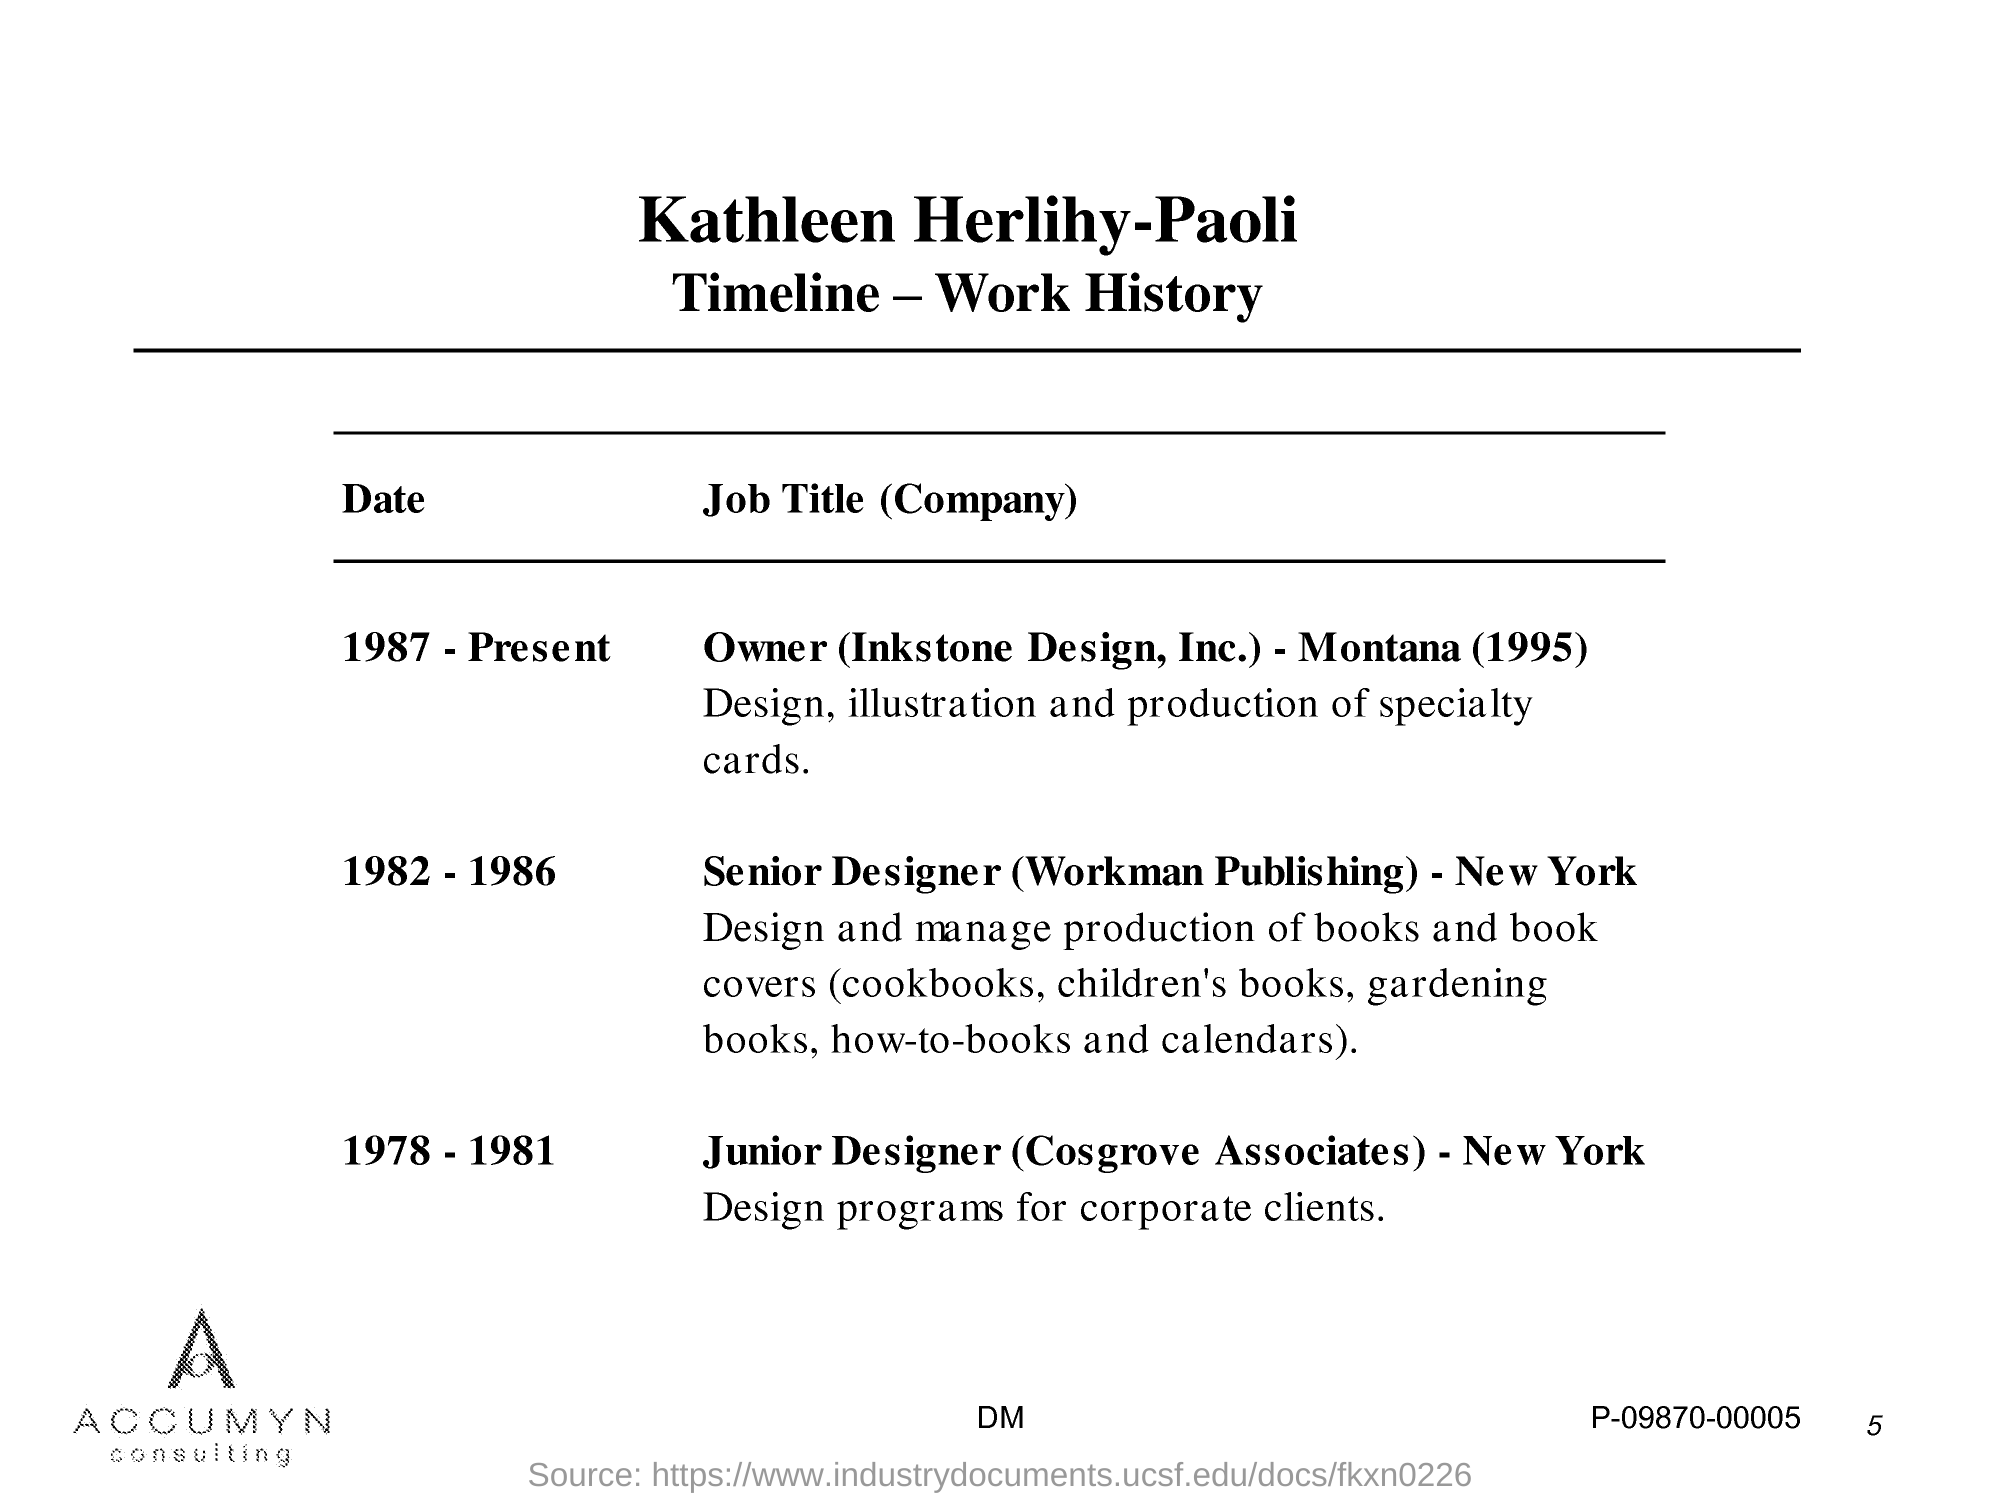List a handful of essential elements in this visual. Kathleen Herlihy-Paoli is the owner of Inkstone Design, Inc. and currently resides in Montana, having been established in 1995. Kathleen Herlihy-Paoli's timeline provides a comprehensive overview of wok history. As a Junior Designer at Cosgrove Associates, Kathleen Herlihy-Paoli was responsible for designing programs for corporate clients, utilizing her skills in graphic design and creative problem-solving to meet the specific needs of each client. Kathleen Herlihy-Paoli worked as a senior designer at Workman Publishing in New York from 1982 to 1986. 